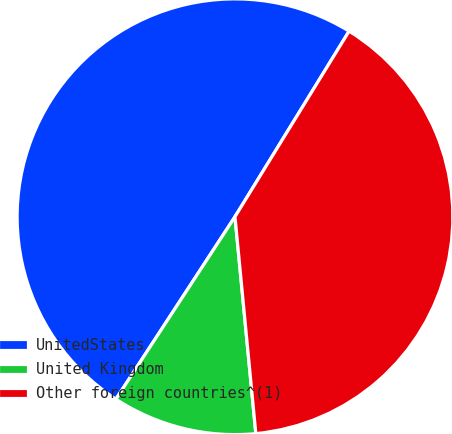Convert chart to OTSL. <chart><loc_0><loc_0><loc_500><loc_500><pie_chart><fcel>UnitedStates<fcel>United Kingdom<fcel>Other foreign countries^(1)<nl><fcel>49.57%<fcel>10.73%<fcel>39.7%<nl></chart> 